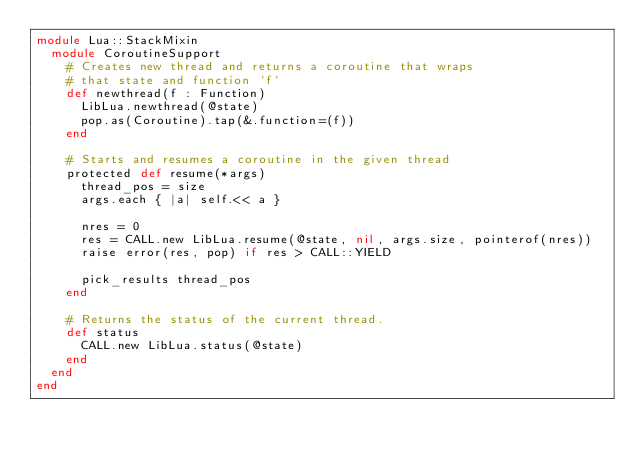Convert code to text. <code><loc_0><loc_0><loc_500><loc_500><_Crystal_>module Lua::StackMixin
  module CoroutineSupport
    # Creates new thread and returns a coroutine that wraps
    # that state and function `f`
    def newthread(f : Function)
      LibLua.newthread(@state)
      pop.as(Coroutine).tap(&.function=(f))
    end

    # Starts and resumes a coroutine in the given thread
    protected def resume(*args)
      thread_pos = size
      args.each { |a| self.<< a }

      nres = 0
      res = CALL.new LibLua.resume(@state, nil, args.size, pointerof(nres))
      raise error(res, pop) if res > CALL::YIELD

      pick_results thread_pos
    end

    # Returns the status of the current thread.
    def status
      CALL.new LibLua.status(@state)
    end
  end
end
</code> 